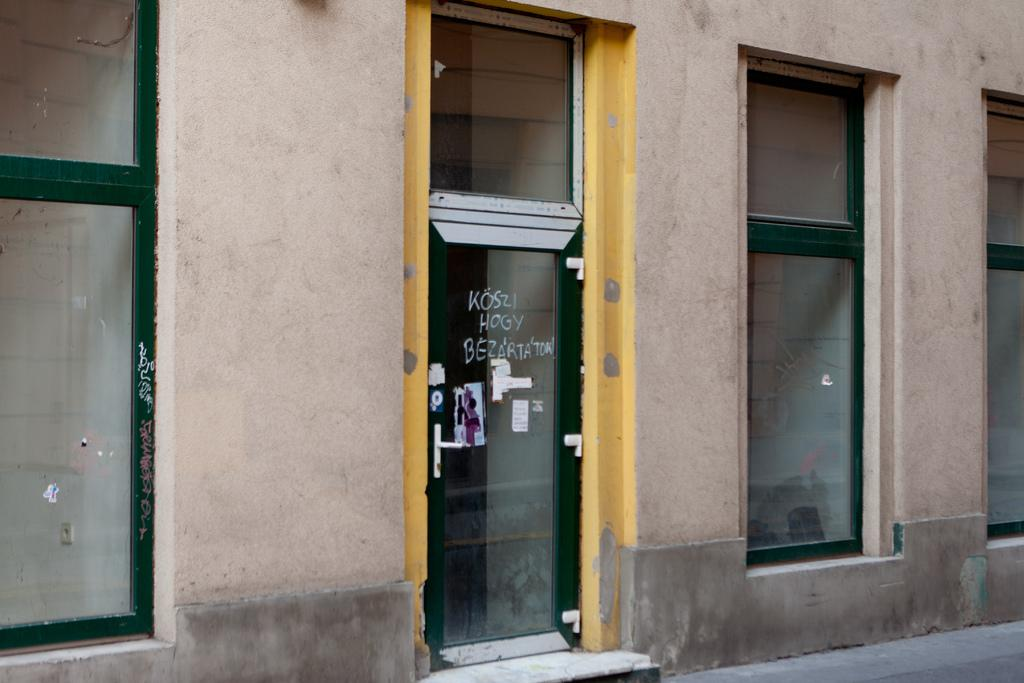What type of structure is visible in the image? There is a building in the image. What objects are located in the front of the image? There are glasses in the front of the image. What is attached to the glasses? Papers are pasted on the glasses. Can you read any text in the image? Yes, there is text visible on the glasses. What type of shirt is the person wearing in the image? There is no person visible in the image, so it is not possible to determine what type of shirt they might be wearing. 